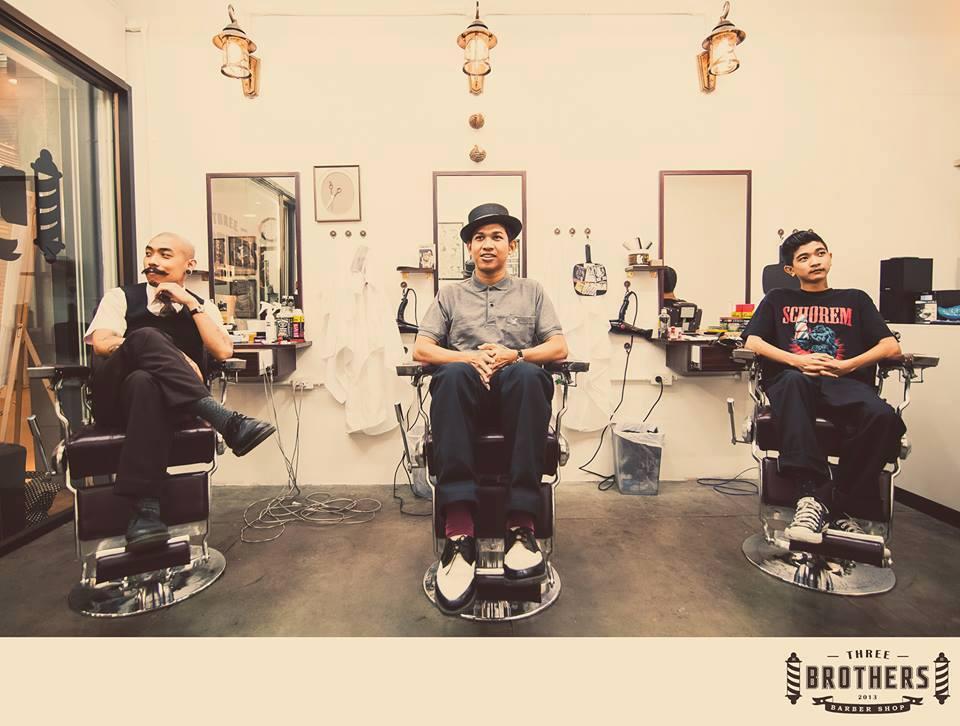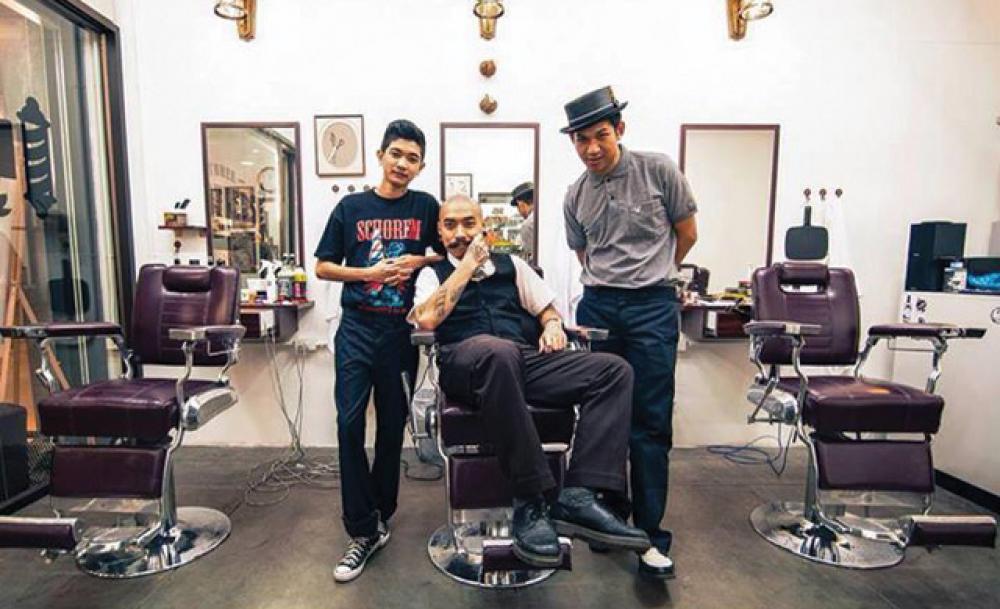The first image is the image on the left, the second image is the image on the right. Considering the images on both sides, is "Everyone is posed for the photo, nobody is going about their business." valid? Answer yes or no. Yes. 